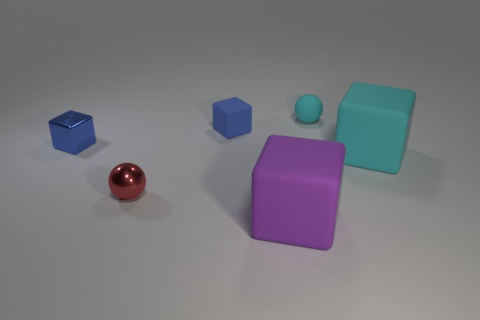Subtract all metallic cubes. How many cubes are left? 3 Subtract all balls. How many objects are left? 4 Subtract all cyan blocks. How many blocks are left? 3 Subtract 2 cubes. How many cubes are left? 2 Subtract all big yellow matte spheres. Subtract all blue matte blocks. How many objects are left? 5 Add 2 small cyan objects. How many small cyan objects are left? 3 Add 6 big rubber balls. How many big rubber balls exist? 6 Add 3 blue matte objects. How many objects exist? 9 Subtract 0 brown blocks. How many objects are left? 6 Subtract all cyan cubes. Subtract all red cylinders. How many cubes are left? 3 